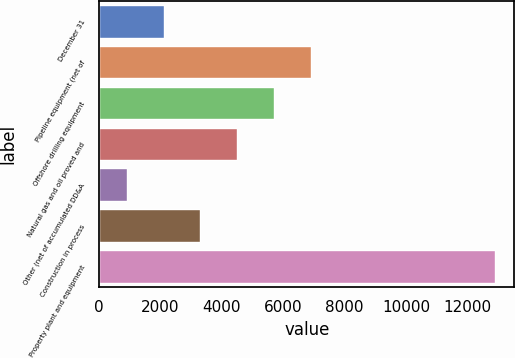<chart> <loc_0><loc_0><loc_500><loc_500><bar_chart><fcel>December 31<fcel>Pipeline equipment (net of<fcel>Offshore drilling equipment<fcel>Natural gas and oil proved and<fcel>Other (net of accumulated DD&A<fcel>Construction in process<fcel>Property plant and equipment<nl><fcel>2097.4<fcel>6895<fcel>5695.6<fcel>4496.2<fcel>898<fcel>3296.8<fcel>12892<nl></chart> 